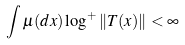<formula> <loc_0><loc_0><loc_500><loc_500>\int \mu ( d x ) \log ^ { + } \left \| T ( x ) \right \| < \infty</formula> 